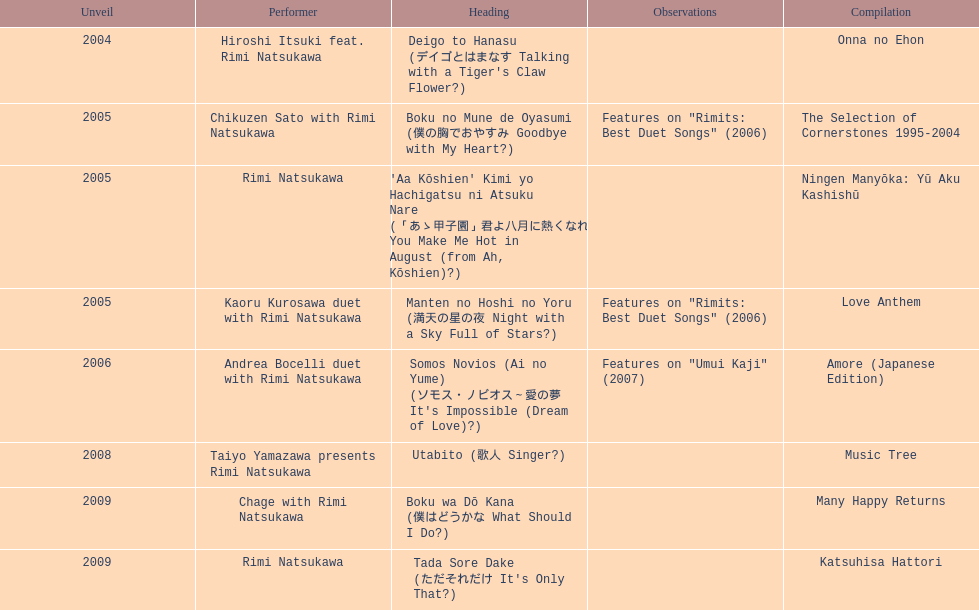Which title has the same notes as night with a sky full of stars? Boku no Mune de Oyasumi (僕の胸でおやすみ Goodbye with My Heart?). 